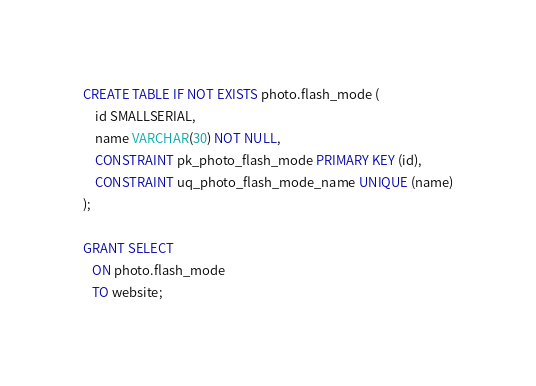Convert code to text. <code><loc_0><loc_0><loc_500><loc_500><_SQL_>CREATE TABLE IF NOT EXISTS photo.flash_mode (
    id SMALLSERIAL,
    name VARCHAR(30) NOT NULL,
    CONSTRAINT pk_photo_flash_mode PRIMARY KEY (id),
    CONSTRAINT uq_photo_flash_mode_name UNIQUE (name)
);

GRANT SELECT
   ON photo.flash_mode
   TO website;
</code> 